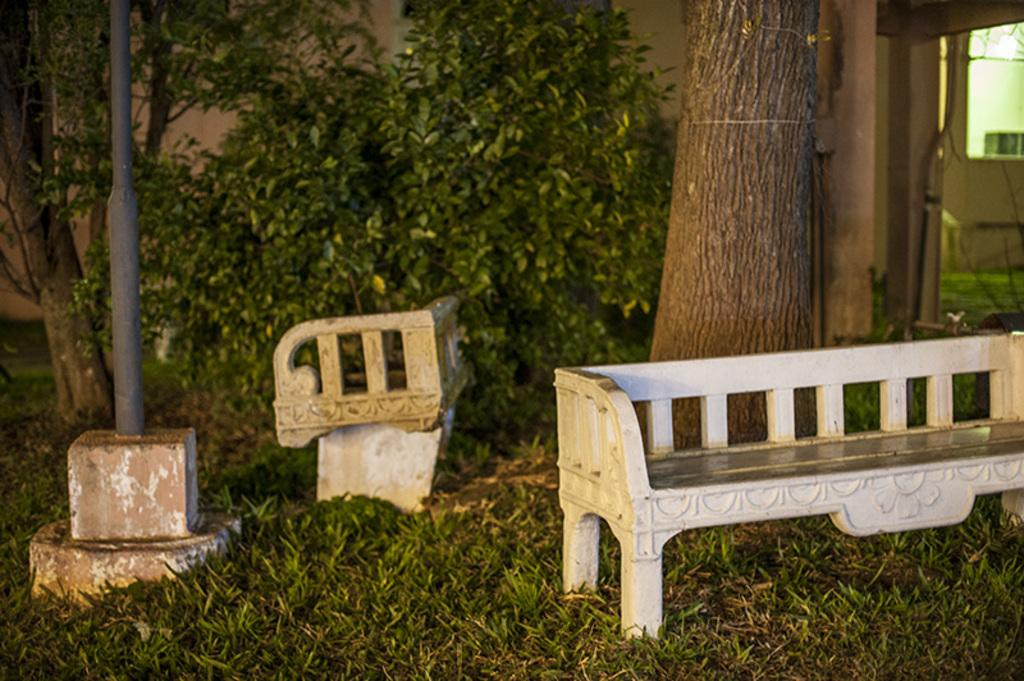What type of seating is present in the image? There are benches in the image. What other elements can be seen in the image besides the benches? There are plants, a pole on the right side, grass visible on the ground, a tree trunk behind a bench, and a few objects in the image. How does the plant react to the earthquake in the image? There is no earthquake present in the image, so the plant's reaction cannot be determined. What color is the paint on the benches in the image? There is no mention of paint or color on the benches in the provided facts, so we cannot determine the color of the paint. 